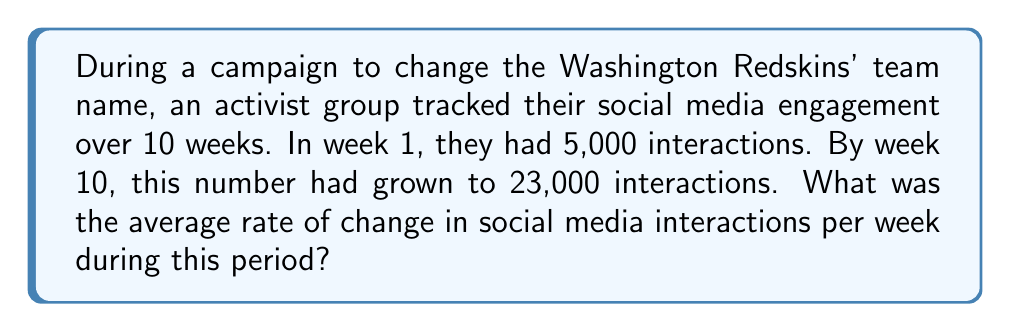Can you solve this math problem? To solve this problem, we need to calculate the rate of change in social media interactions over the given time period. Let's break it down step-by-step:

1. Identify the key information:
   - Initial interactions (week 1): 5,000
   - Final interactions (week 10): 23,000
   - Time period: 10 weeks

2. Calculate the total change in interactions:
   $\text{Total change} = \text{Final value} - \text{Initial value}$
   $\text{Total change} = 23,000 - 5,000 = 18,000$ interactions

3. Calculate the time interval:
   $\text{Time interval} = \text{Final week} - \text{Initial week}$
   $\text{Time interval} = 10 - 1 = 9$ weeks

4. Apply the rate of change formula:
   $$\text{Rate of change} = \frac{\text{Change in quantity}}{\text{Change in time}}$$

   $$\text{Rate of change} = \frac{18,000 \text{ interactions}}{9 \text{ weeks}}$$

5. Simplify the fraction:
   $$\text{Rate of change} = 2,000 \text{ interactions per week}$$

Therefore, the average rate of change in social media interactions was 2,000 per week during the 10-week campaign.
Answer: 2,000 interactions/week 